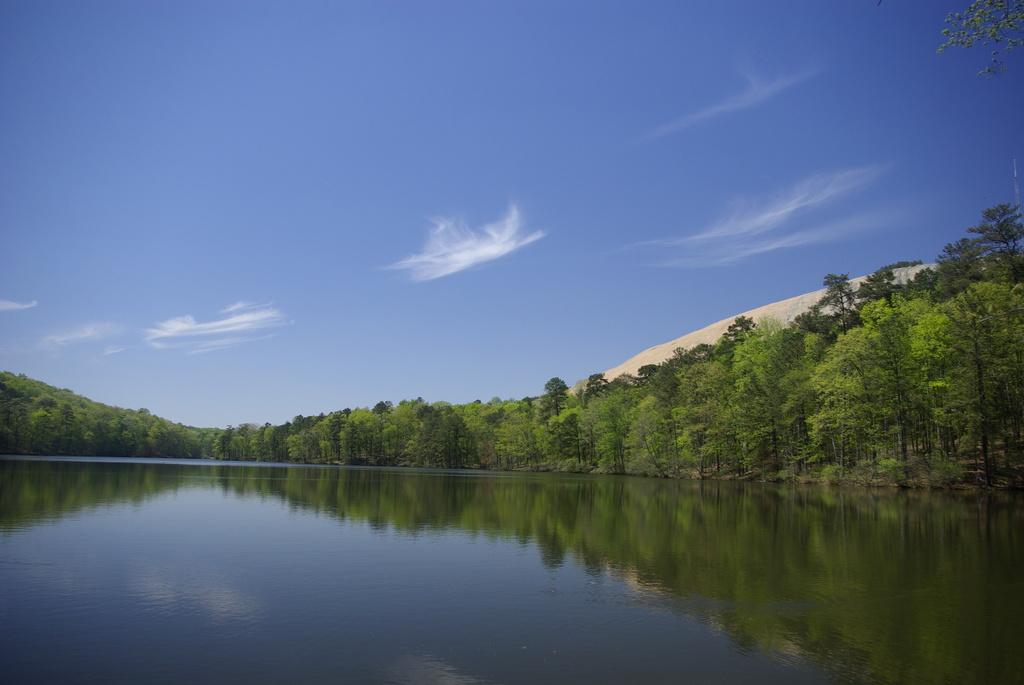What type of vegetation can be seen in the image? There are green trees in the image. What natural element is visible besides the trees? There is water visible in the image. What colors can be seen in the sky in the image? The sky is blue and white in color. How many girls are wearing shoes in the image? There are no girls or shoes present in the image. 